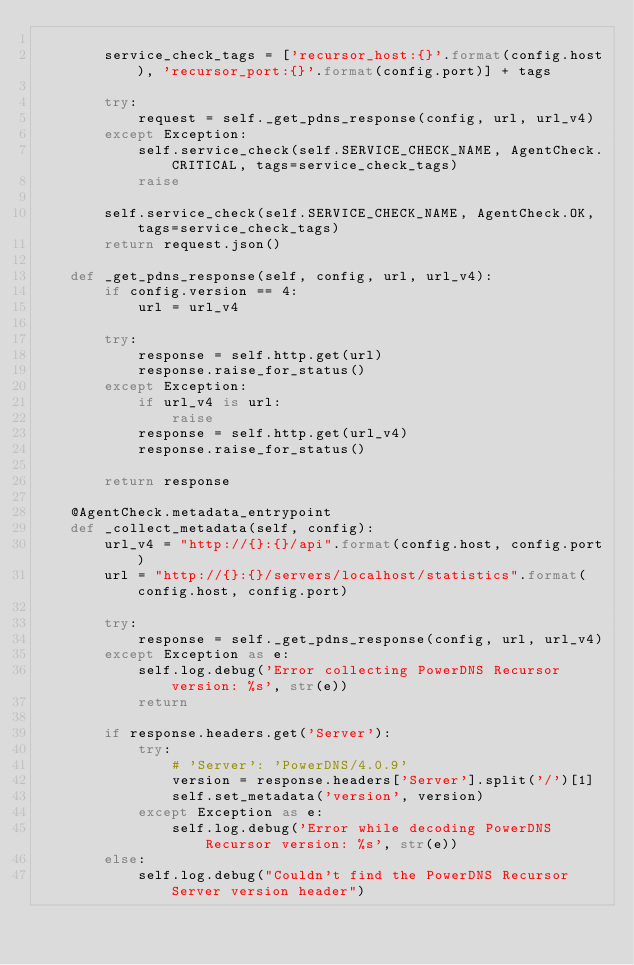Convert code to text. <code><loc_0><loc_0><loc_500><loc_500><_Python_>
        service_check_tags = ['recursor_host:{}'.format(config.host), 'recursor_port:{}'.format(config.port)] + tags

        try:
            request = self._get_pdns_response(config, url, url_v4)
        except Exception:
            self.service_check(self.SERVICE_CHECK_NAME, AgentCheck.CRITICAL, tags=service_check_tags)
            raise

        self.service_check(self.SERVICE_CHECK_NAME, AgentCheck.OK, tags=service_check_tags)
        return request.json()

    def _get_pdns_response(self, config, url, url_v4):
        if config.version == 4:
            url = url_v4

        try:
            response = self.http.get(url)
            response.raise_for_status()
        except Exception:
            if url_v4 is url:
                raise
            response = self.http.get(url_v4)
            response.raise_for_status()

        return response

    @AgentCheck.metadata_entrypoint
    def _collect_metadata(self, config):
        url_v4 = "http://{}:{}/api".format(config.host, config.port)
        url = "http://{}:{}/servers/localhost/statistics".format(config.host, config.port)

        try:
            response = self._get_pdns_response(config, url, url_v4)
        except Exception as e:
            self.log.debug('Error collecting PowerDNS Recursor version: %s', str(e))
            return

        if response.headers.get('Server'):
            try:
                # 'Server': 'PowerDNS/4.0.9'
                version = response.headers['Server'].split('/')[1]
                self.set_metadata('version', version)
            except Exception as e:
                self.log.debug('Error while decoding PowerDNS Recursor version: %s', str(e))
        else:
            self.log.debug("Couldn't find the PowerDNS Recursor Server version header")
</code> 